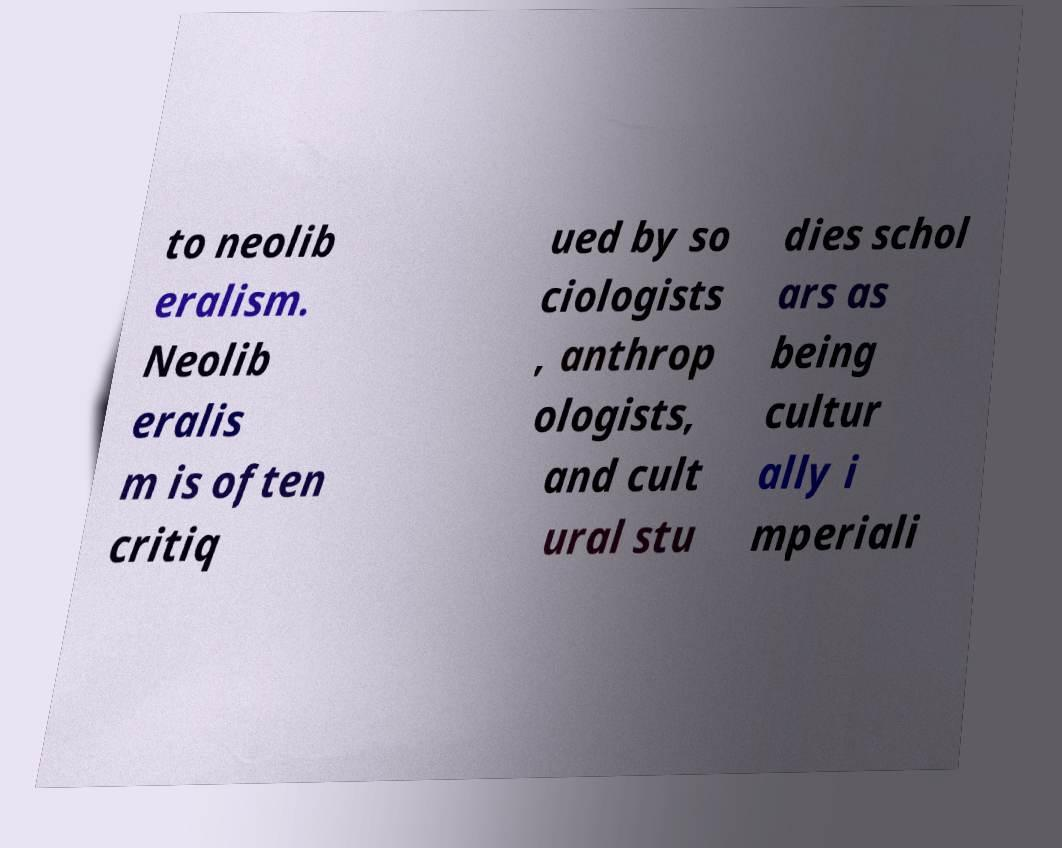I need the written content from this picture converted into text. Can you do that? to neolib eralism. Neolib eralis m is often critiq ued by so ciologists , anthrop ologists, and cult ural stu dies schol ars as being cultur ally i mperiali 